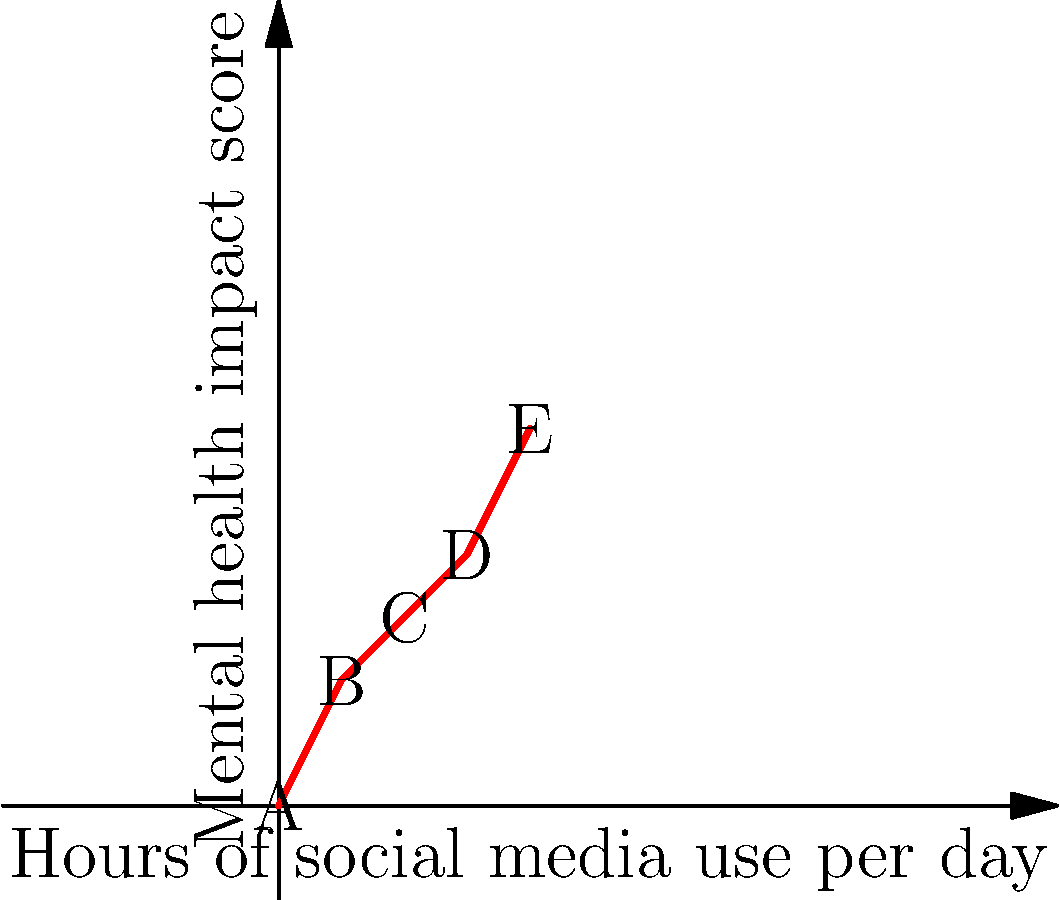The graph shows the relationship between daily social media usage and mental health impact scores. Which point represents the most significant increase in mental health impact relative to the previous data point, potentially indicating a critical threshold for social media usage? To determine the point with the most significant increase in mental health impact relative to the previous data point, we need to calculate the rate of change between each consecutive pair of points:

1. From A (0,0) to B (1,2):
   Rate of change = (2 - 0) / (1 - 0) = 2

2. From B (1,2) to C (2,3):
   Rate of change = (3 - 2) / (2 - 1) = 1

3. From C (2,3) to D (3,4):
   Rate of change = (4 - 3) / (3 - 2) = 1

4. From D (3,4) to E (4,6):
   Rate of change = (6 - 4) / (4 - 3) = 2

The highest rate of change is 2, which occurs twice: between points A and B, and between points D and E. However, the question asks for the most significant increase relative to the previous data point. Since the increase from D to E occurs after a longer period of social media usage, it represents a more critical threshold.

Therefore, point E (4,6) represents the most significant increase in mental health impact relative to the previous data point, potentially indicating a critical threshold for social media usage.
Answer: E 